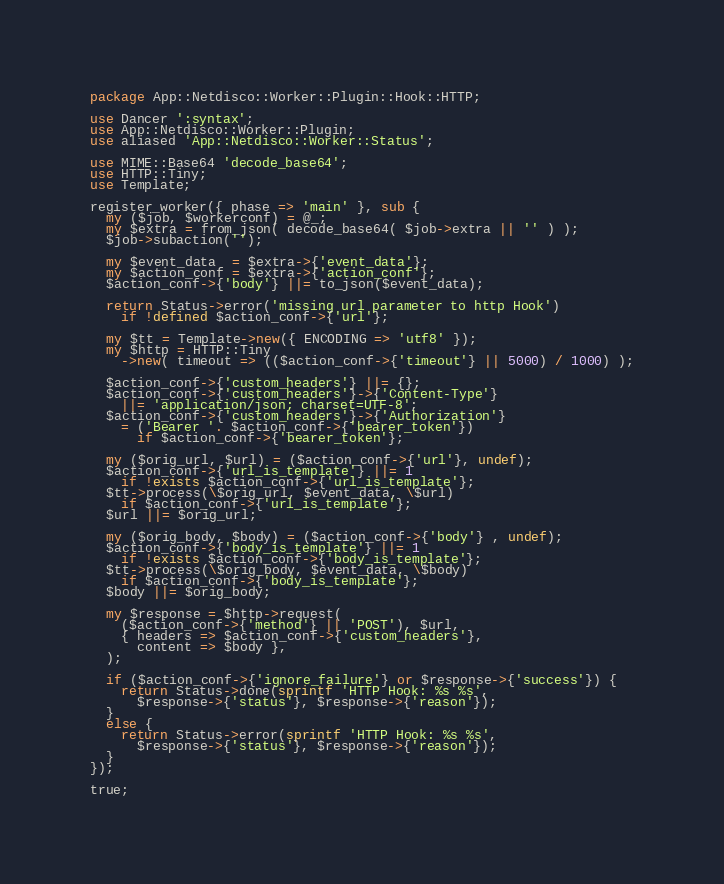<code> <loc_0><loc_0><loc_500><loc_500><_Perl_>package App::Netdisco::Worker::Plugin::Hook::HTTP;

use Dancer ':syntax';
use App::Netdisco::Worker::Plugin;
use aliased 'App::Netdisco::Worker::Status';

use MIME::Base64 'decode_base64';
use HTTP::Tiny;
use Template;

register_worker({ phase => 'main' }, sub {
  my ($job, $workerconf) = @_;
  my $extra = from_json( decode_base64( $job->extra || '' ) );
  $job->subaction('');

  my $event_data  = $extra->{'event_data'};
  my $action_conf = $extra->{'action_conf'};
  $action_conf->{'body'} ||= to_json($event_data);

  return Status->error('missing url parameter to http Hook')
    if !defined $action_conf->{'url'};

  my $tt = Template->new({ ENCODING => 'utf8' });
  my $http = HTTP::Tiny
    ->new( timeout => (($action_conf->{'timeout'} || 5000) / 1000) );

  $action_conf->{'custom_headers'} ||= {};
  $action_conf->{'custom_headers'}->{'Content-Type'}
    ||= 'application/json; charset=UTF-8';
  $action_conf->{'custom_headers'}->{'Authorization'}
    = ('Bearer '. $action_conf->{'bearer_token'})
      if $action_conf->{'bearer_token'};

  my ($orig_url, $url) = ($action_conf->{'url'}, undef);
  $action_conf->{'url_is_template'} ||= 1
    if !exists $action_conf->{'url_is_template'};
  $tt->process(\$orig_url, $event_data, \$url)
    if $action_conf->{'url_is_template'};
  $url ||= $orig_url;

  my ($orig_body, $body) = ($action_conf->{'body'} , undef);
  $action_conf->{'body_is_template'} ||= 1
    if !exists $action_conf->{'body_is_template'};
  $tt->process(\$orig_body, $event_data, \$body)
    if $action_conf->{'body_is_template'};
  $body ||= $orig_body;

  my $response = $http->request(
    ($action_conf->{'method'} || 'POST'), $url,
    { headers => $action_conf->{'custom_headers'},
      content => $body },
  );

  if ($action_conf->{'ignore_failure'} or $response->{'success'}) {
    return Status->done(sprintf 'HTTP Hook: %s %s',
      $response->{'status'}, $response->{'reason'});
  }
  else {
    return Status->error(sprintf 'HTTP Hook: %s %s',
      $response->{'status'}, $response->{'reason'});
  }
});

true;
</code> 